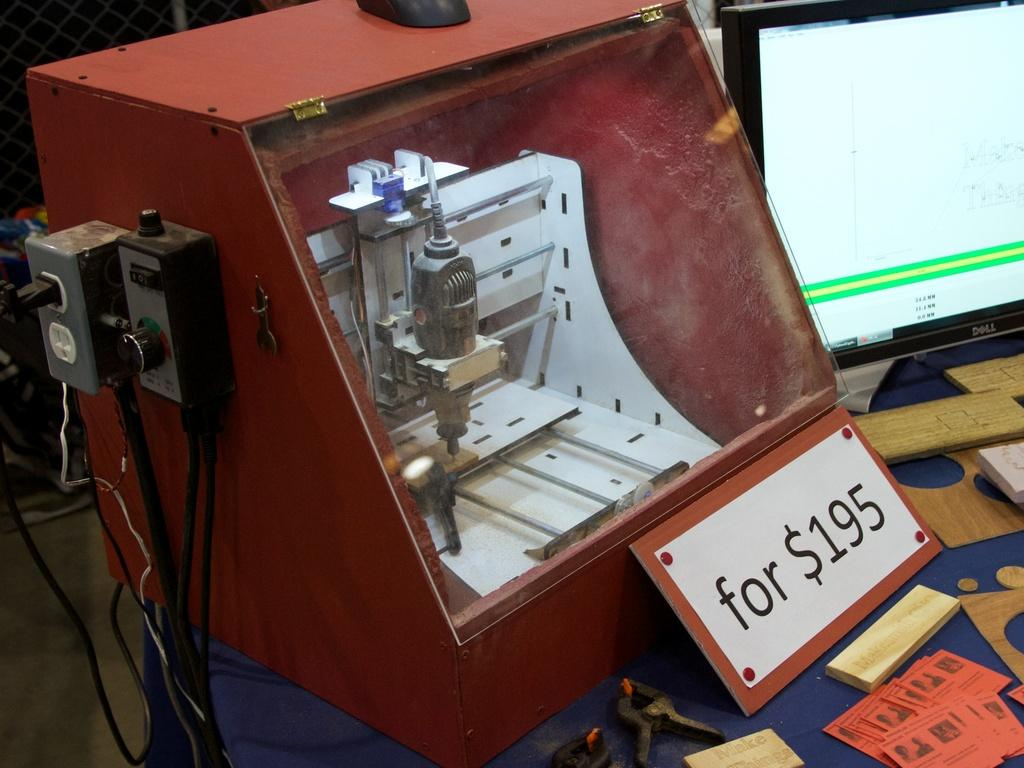<image>
Write a terse but informative summary of the picture. A display case next to a computer monitor shows a carving machine which has a cost of $195. 